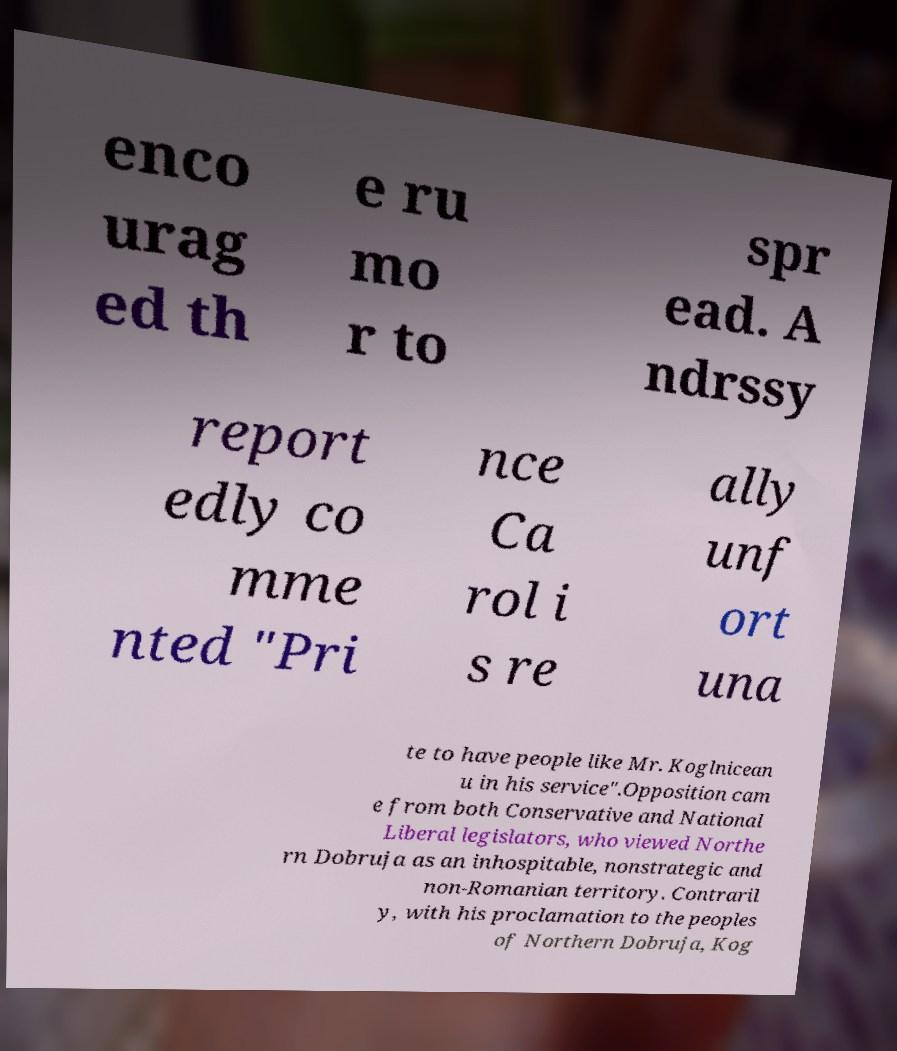Please identify and transcribe the text found in this image. enco urag ed th e ru mo r to spr ead. A ndrssy report edly co mme nted "Pri nce Ca rol i s re ally unf ort una te to have people like Mr. Koglnicean u in his service".Opposition cam e from both Conservative and National Liberal legislators, who viewed Northe rn Dobruja as an inhospitable, nonstrategic and non-Romanian territory. Contraril y, with his proclamation to the peoples of Northern Dobruja, Kog 